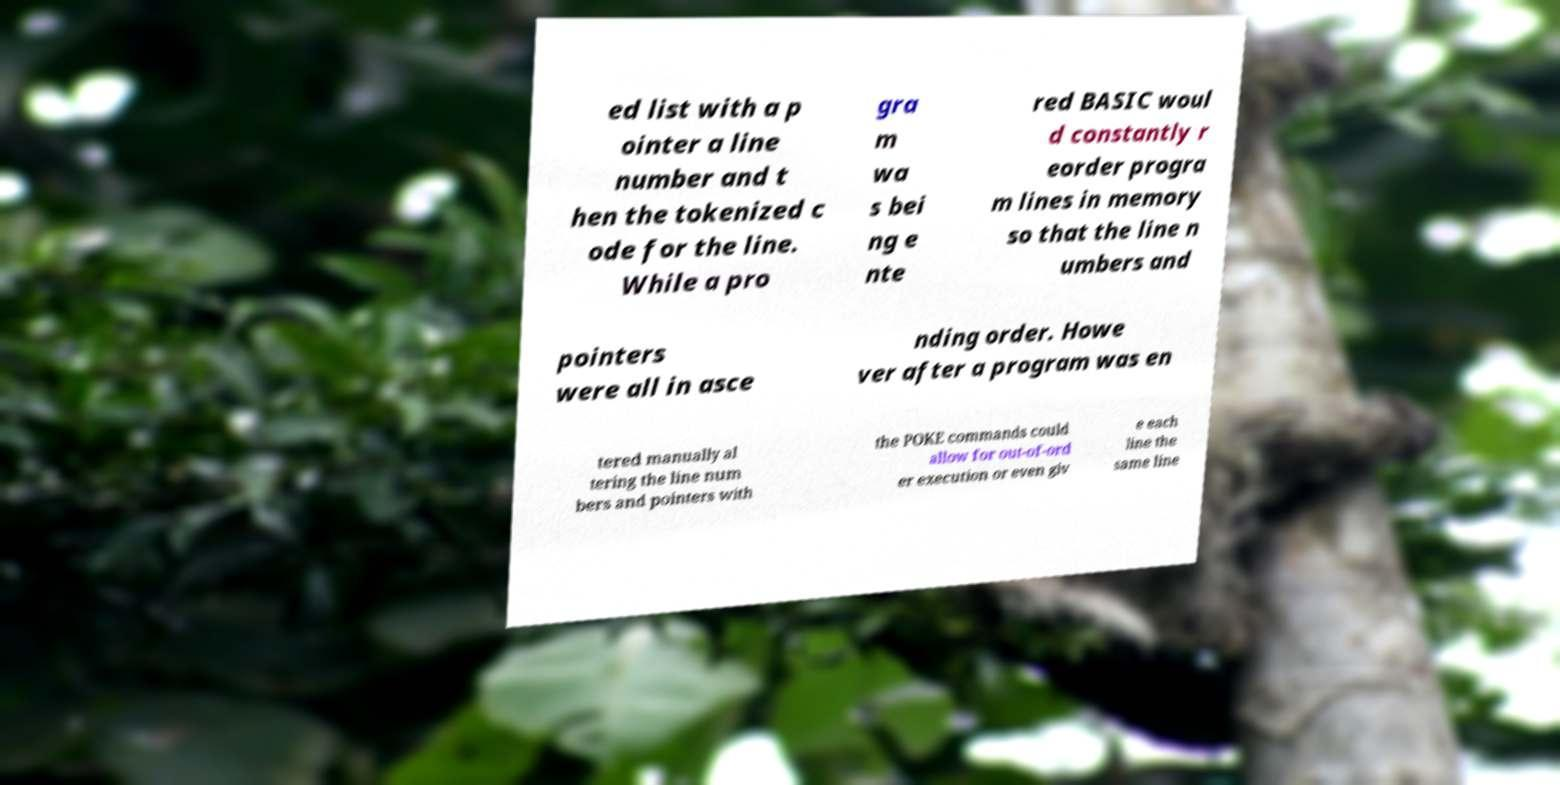Could you assist in decoding the text presented in this image and type it out clearly? ed list with a p ointer a line number and t hen the tokenized c ode for the line. While a pro gra m wa s bei ng e nte red BASIC woul d constantly r eorder progra m lines in memory so that the line n umbers and pointers were all in asce nding order. Howe ver after a program was en tered manually al tering the line num bers and pointers with the POKE commands could allow for out-of-ord er execution or even giv e each line the same line 